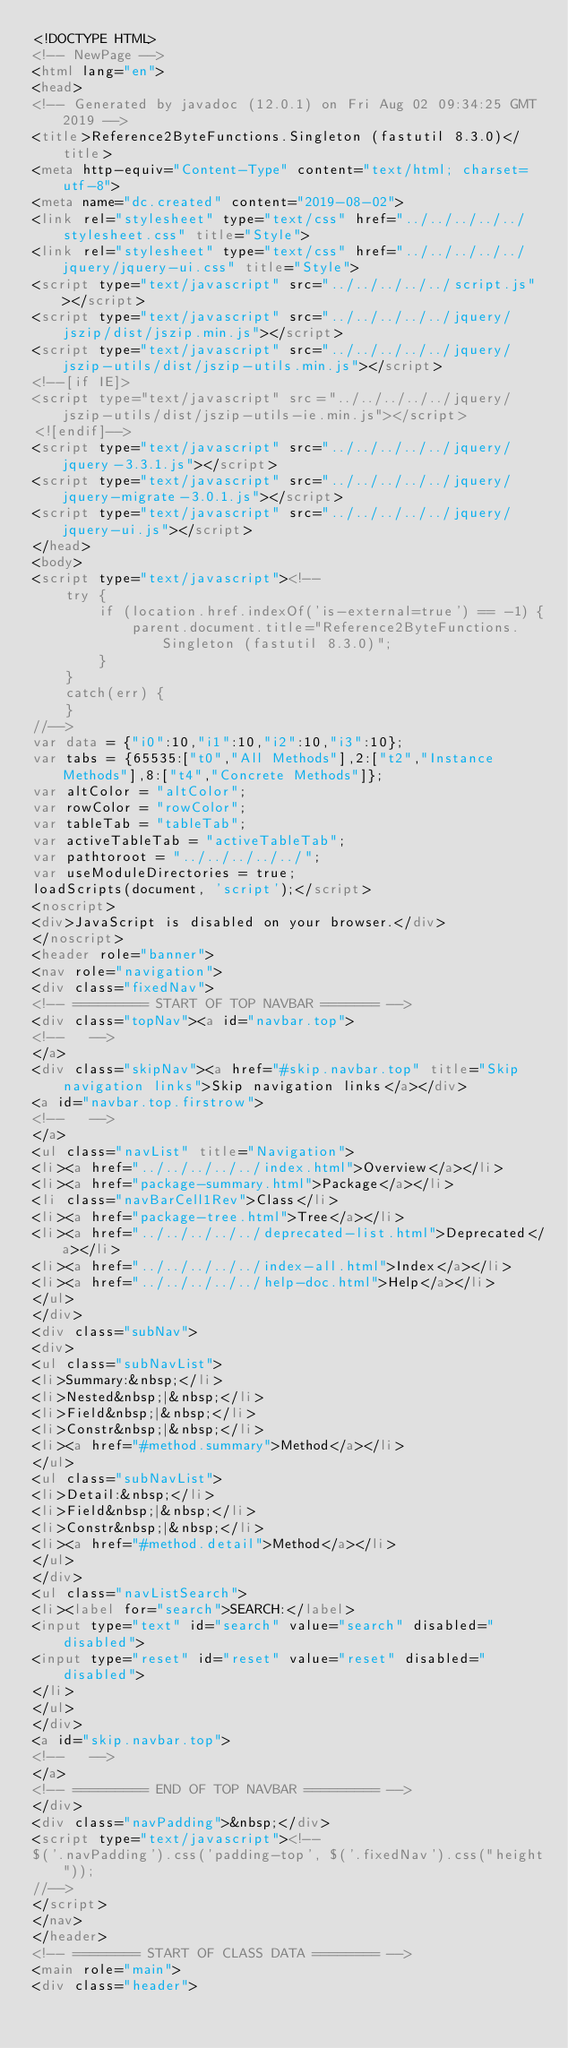<code> <loc_0><loc_0><loc_500><loc_500><_HTML_><!DOCTYPE HTML>
<!-- NewPage -->
<html lang="en">
<head>
<!-- Generated by javadoc (12.0.1) on Fri Aug 02 09:34:25 GMT 2019 -->
<title>Reference2ByteFunctions.Singleton (fastutil 8.3.0)</title>
<meta http-equiv="Content-Type" content="text/html; charset=utf-8">
<meta name="dc.created" content="2019-08-02">
<link rel="stylesheet" type="text/css" href="../../../../../stylesheet.css" title="Style">
<link rel="stylesheet" type="text/css" href="../../../../../jquery/jquery-ui.css" title="Style">
<script type="text/javascript" src="../../../../../script.js"></script>
<script type="text/javascript" src="../../../../../jquery/jszip/dist/jszip.min.js"></script>
<script type="text/javascript" src="../../../../../jquery/jszip-utils/dist/jszip-utils.min.js"></script>
<!--[if IE]>
<script type="text/javascript" src="../../../../../jquery/jszip-utils/dist/jszip-utils-ie.min.js"></script>
<![endif]-->
<script type="text/javascript" src="../../../../../jquery/jquery-3.3.1.js"></script>
<script type="text/javascript" src="../../../../../jquery/jquery-migrate-3.0.1.js"></script>
<script type="text/javascript" src="../../../../../jquery/jquery-ui.js"></script>
</head>
<body>
<script type="text/javascript"><!--
    try {
        if (location.href.indexOf('is-external=true') == -1) {
            parent.document.title="Reference2ByteFunctions.Singleton (fastutil 8.3.0)";
        }
    }
    catch(err) {
    }
//-->
var data = {"i0":10,"i1":10,"i2":10,"i3":10};
var tabs = {65535:["t0","All Methods"],2:["t2","Instance Methods"],8:["t4","Concrete Methods"]};
var altColor = "altColor";
var rowColor = "rowColor";
var tableTab = "tableTab";
var activeTableTab = "activeTableTab";
var pathtoroot = "../../../../../";
var useModuleDirectories = true;
loadScripts(document, 'script');</script>
<noscript>
<div>JavaScript is disabled on your browser.</div>
</noscript>
<header role="banner">
<nav role="navigation">
<div class="fixedNav">
<!-- ========= START OF TOP NAVBAR ======= -->
<div class="topNav"><a id="navbar.top">
<!--   -->
</a>
<div class="skipNav"><a href="#skip.navbar.top" title="Skip navigation links">Skip navigation links</a></div>
<a id="navbar.top.firstrow">
<!--   -->
</a>
<ul class="navList" title="Navigation">
<li><a href="../../../../../index.html">Overview</a></li>
<li><a href="package-summary.html">Package</a></li>
<li class="navBarCell1Rev">Class</li>
<li><a href="package-tree.html">Tree</a></li>
<li><a href="../../../../../deprecated-list.html">Deprecated</a></li>
<li><a href="../../../../../index-all.html">Index</a></li>
<li><a href="../../../../../help-doc.html">Help</a></li>
</ul>
</div>
<div class="subNav">
<div>
<ul class="subNavList">
<li>Summary:&nbsp;</li>
<li>Nested&nbsp;|&nbsp;</li>
<li>Field&nbsp;|&nbsp;</li>
<li>Constr&nbsp;|&nbsp;</li>
<li><a href="#method.summary">Method</a></li>
</ul>
<ul class="subNavList">
<li>Detail:&nbsp;</li>
<li>Field&nbsp;|&nbsp;</li>
<li>Constr&nbsp;|&nbsp;</li>
<li><a href="#method.detail">Method</a></li>
</ul>
</div>
<ul class="navListSearch">
<li><label for="search">SEARCH:</label>
<input type="text" id="search" value="search" disabled="disabled">
<input type="reset" id="reset" value="reset" disabled="disabled">
</li>
</ul>
</div>
<a id="skip.navbar.top">
<!--   -->
</a>
<!-- ========= END OF TOP NAVBAR ========= -->
</div>
<div class="navPadding">&nbsp;</div>
<script type="text/javascript"><!--
$('.navPadding').css('padding-top', $('.fixedNav').css("height"));
//-->
</script>
</nav>
</header>
<!-- ======== START OF CLASS DATA ======== -->
<main role="main">
<div class="header"></code> 